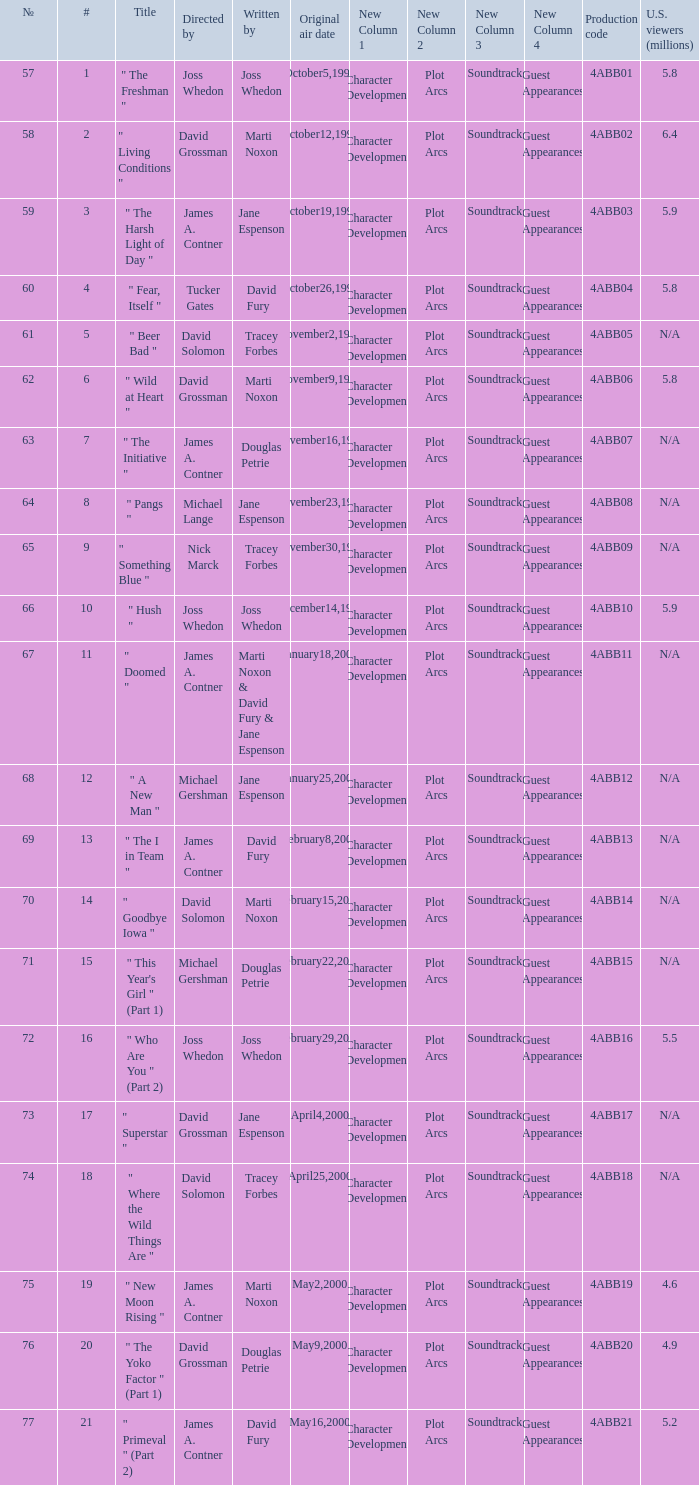What is the title of episode No. 65? " Something Blue ". 